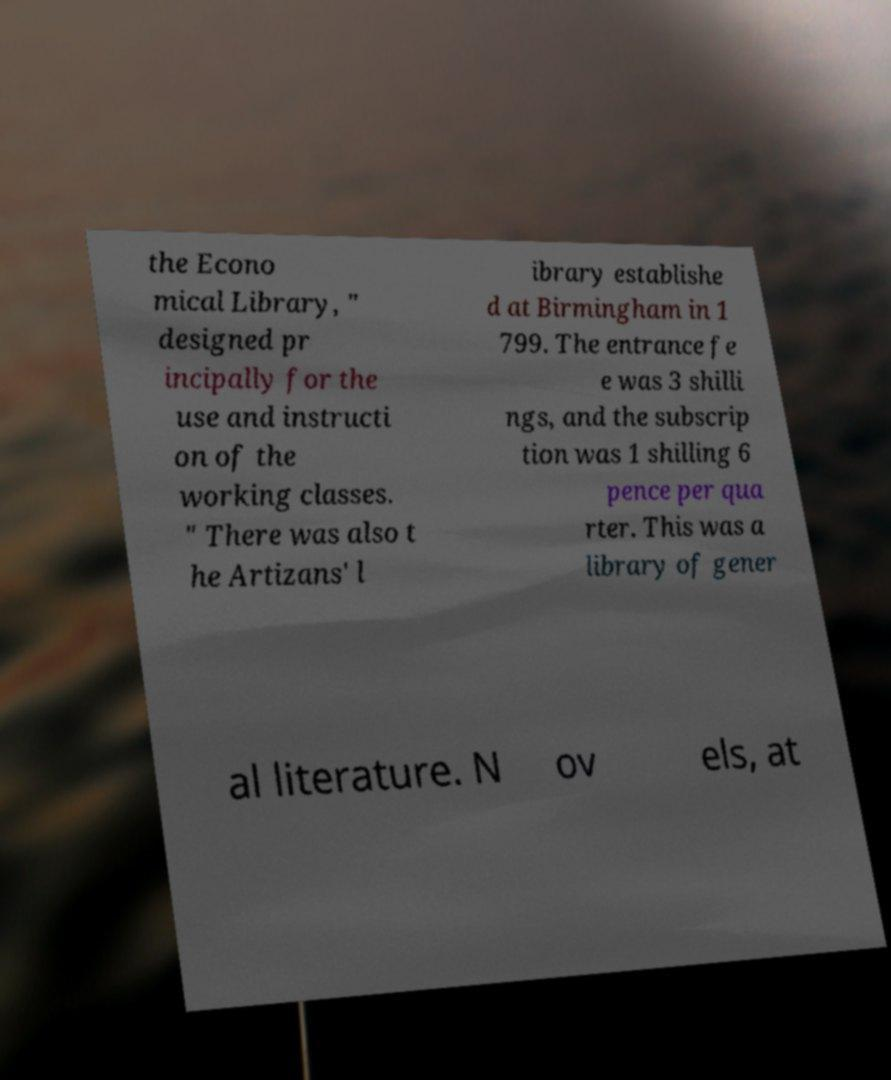There's text embedded in this image that I need extracted. Can you transcribe it verbatim? the Econo mical Library, " designed pr incipally for the use and instructi on of the working classes. " There was also t he Artizans' l ibrary establishe d at Birmingham in 1 799. The entrance fe e was 3 shilli ngs, and the subscrip tion was 1 shilling 6 pence per qua rter. This was a library of gener al literature. N ov els, at 